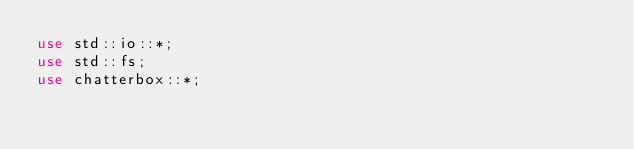<code> <loc_0><loc_0><loc_500><loc_500><_Rust_>use std::io::*;
use std::fs;
use chatterbox::*;</code> 